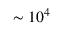Convert formula to latex. <formula><loc_0><loc_0><loc_500><loc_500>\sim 1 0 ^ { 4 }</formula> 